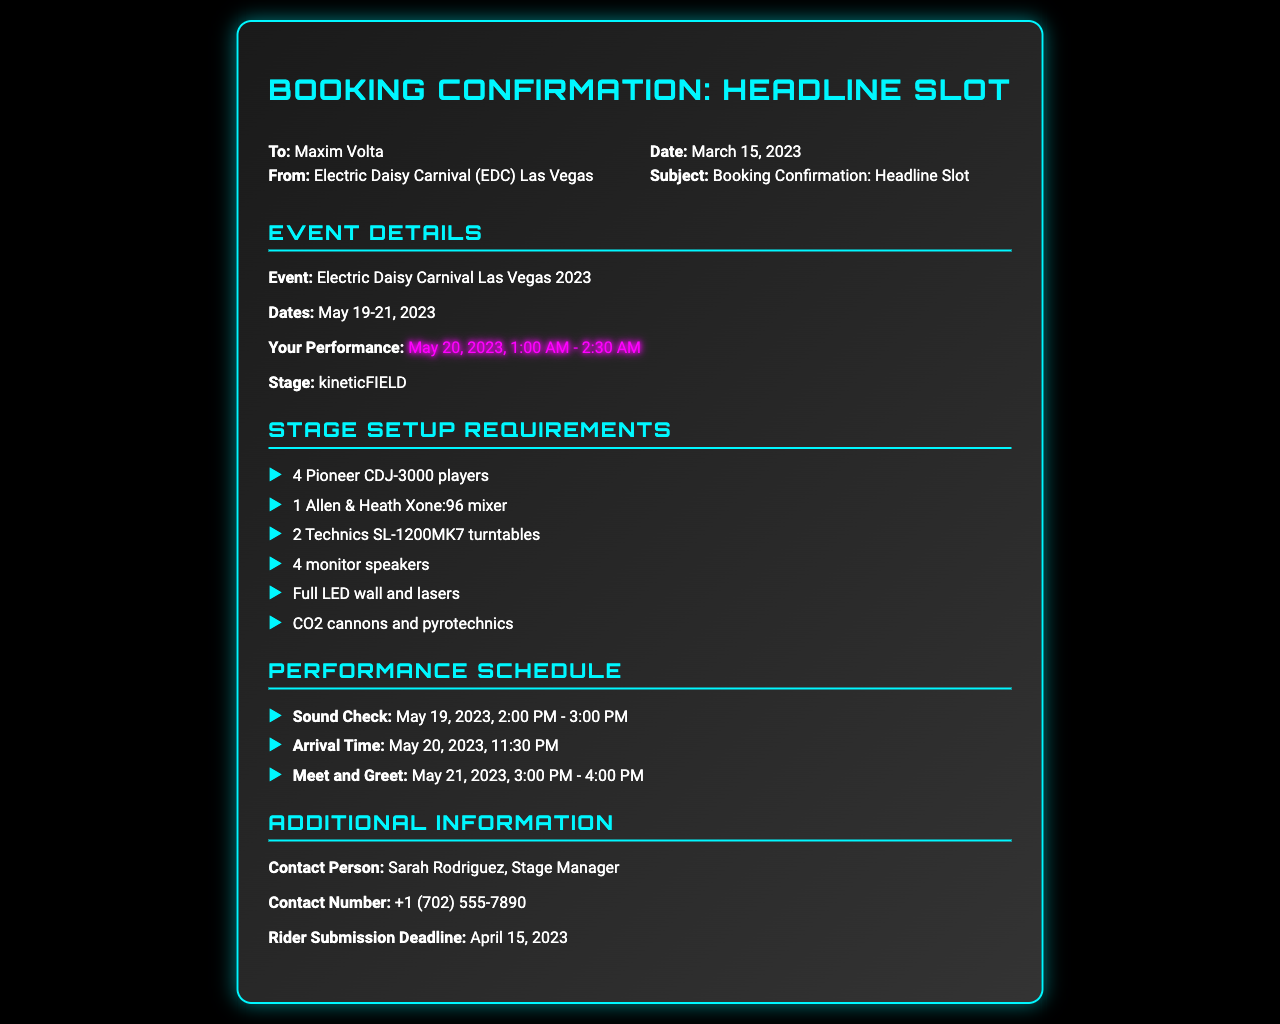What is the name of the festival? The festival mentioned in the document is the Electric Daisy Carnival.
Answer: Electric Daisy Carnival What are the performance dates? The performance dates for the event are mentioned as May 19-21, 2023.
Answer: May 19-21, 2023 What time is the performance scheduled? The performance time listed in the document is from 1:00 AM to 2:30 AM on May 20, 2023.
Answer: 1:00 AM - 2:30 AM Who is the contact person? The document specifies the contact person as Sarah Rodriguez.
Answer: Sarah Rodriguez What equipment is required? The stage setup requirements list several items, including CDJ-3000 players, a mixer, and turntables.
Answer: 4 Pioneer CDJ-3000 players When is the rider submission deadline? The rider submission deadline is stated in the document as April 15, 2023.
Answer: April 15, 2023 What is the stage name? The stage name mentioned in the document is kineticFIELD.
Answer: kineticFIELD What is the sound check time? The sound check time is provided as May 19, 2023, from 2:00 PM to 3:00 PM.
Answer: May 19, 2023, 2:00 PM - 3:00 PM When is the arrival time? The document states the arrival time for the performance as 11:30 PM on May 20, 2023.
Answer: 11:30 PM 